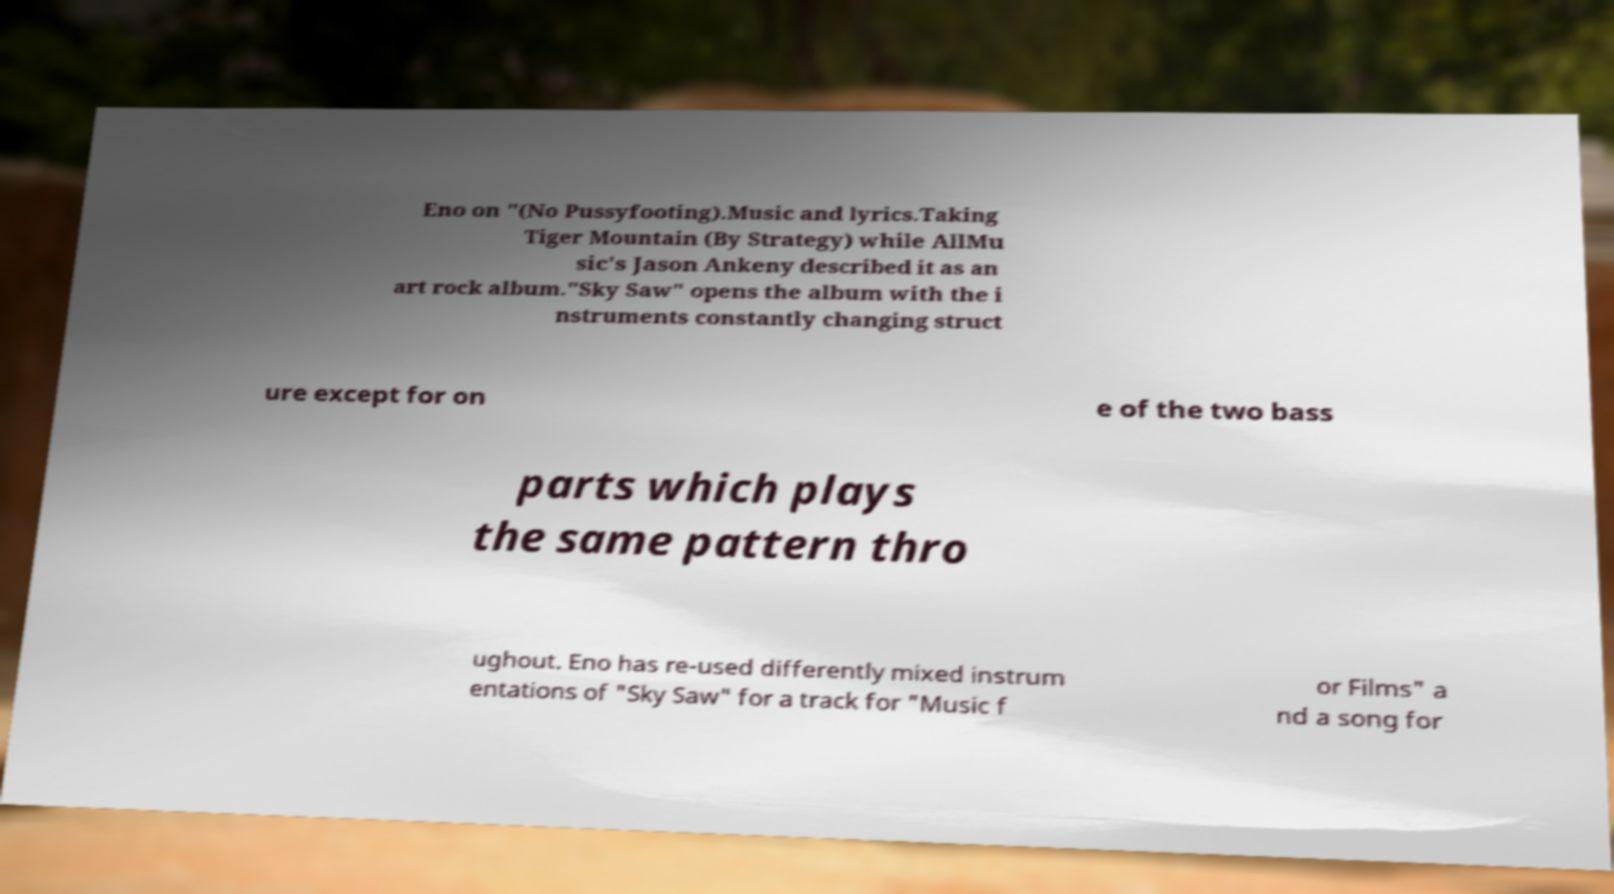Could you assist in decoding the text presented in this image and type it out clearly? Eno on "(No Pussyfooting).Music and lyrics.Taking Tiger Mountain (By Strategy) while AllMu sic's Jason Ankeny described it as an art rock album."Sky Saw" opens the album with the i nstruments constantly changing struct ure except for on e of the two bass parts which plays the same pattern thro ughout. Eno has re-used differently mixed instrum entations of "Sky Saw" for a track for "Music f or Films" a nd a song for 